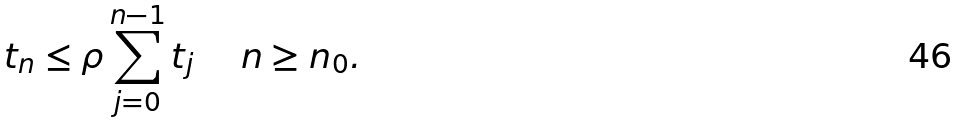Convert formula to latex. <formula><loc_0><loc_0><loc_500><loc_500>t _ { n } \leq \rho \sum _ { j = 0 } ^ { n - 1 } t _ { j } \quad \ n \geq n _ { 0 } .</formula> 